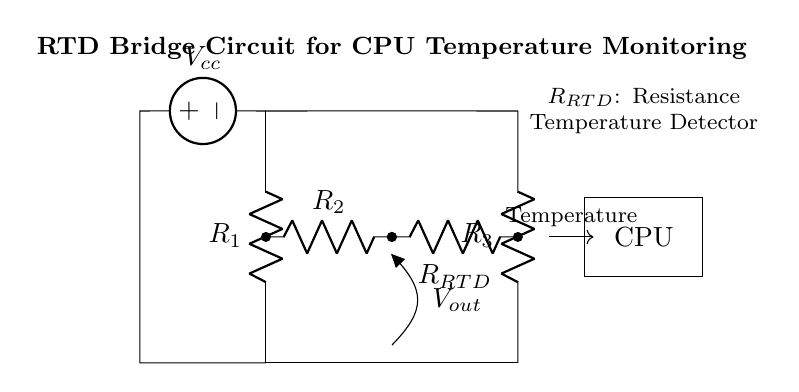What type of circuit is depicted? This circuit is a bridge circuit designed for measuring temperature through a resistance temperature detector (RTD). It employs a Wheatstone bridge configuration to balance and detect changes in resistance caused by temperature variations.
Answer: bridge circuit What does the symbol \( V_{cc} \) represent? The symbol \( V_{cc} \) represents the supply voltage for the circuit, indicating the power source connected to the circuit for its operation.
Answer: supply voltage How many resistors are used in this circuit? The circuit includes four resistors: \( R_1 \), \( R_2 \), \( R_3 \), and \( R_{RTD} \). These resistors serve various roles, with \( R_{RTD} \) specifically being the sensor.
Answer: four resistors What is the role of \( R_{RTD} \)? \( R_{RTD} \) represents the resistance temperature detector which varies its resistance based on temperature changes. This variation is what the bridge circuit measures.
Answer: sensor How is the output voltage \( V_{out} \) taken from the bridge? The output voltage \( V_{out} \) is taken from the midpoint between resistors \( R_2 \) and \( R_{RTD} \). This point represents the voltage difference due to the changes in resistance in the bridge.
Answer: midpoint of \( R_2 \) and \( R_{RTD} \) What is the connection between the CPU and the bridge circuit? The CPU receives the temperature information as an output from the bridge circuit, which processes the resistance change and allows for monitoring the CPU's temperature.
Answer: output to CPU 